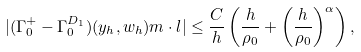Convert formula to latex. <formula><loc_0><loc_0><loc_500><loc_500>| ( \Gamma ^ { + } _ { 0 } - \Gamma ^ { D _ { 1 } } _ { 0 } ) ( y _ { h } , w _ { h } ) m \cdot l | \leq \frac { C } { h } \left ( \frac { h } { \rho _ { 0 } } + \left ( \frac { h } { \rho _ { 0 } } \right ) ^ { \alpha } \right ) ,</formula> 